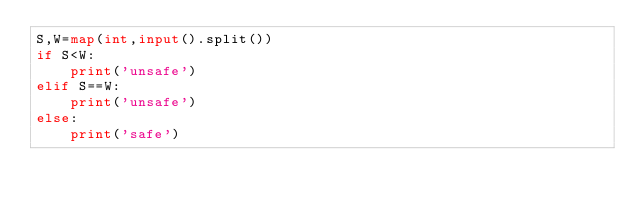Convert code to text. <code><loc_0><loc_0><loc_500><loc_500><_Python_>S,W=map(int,input().split())
if S<W:
    print('unsafe')
elif S==W:
    print('unsafe')
else:
    print('safe')</code> 